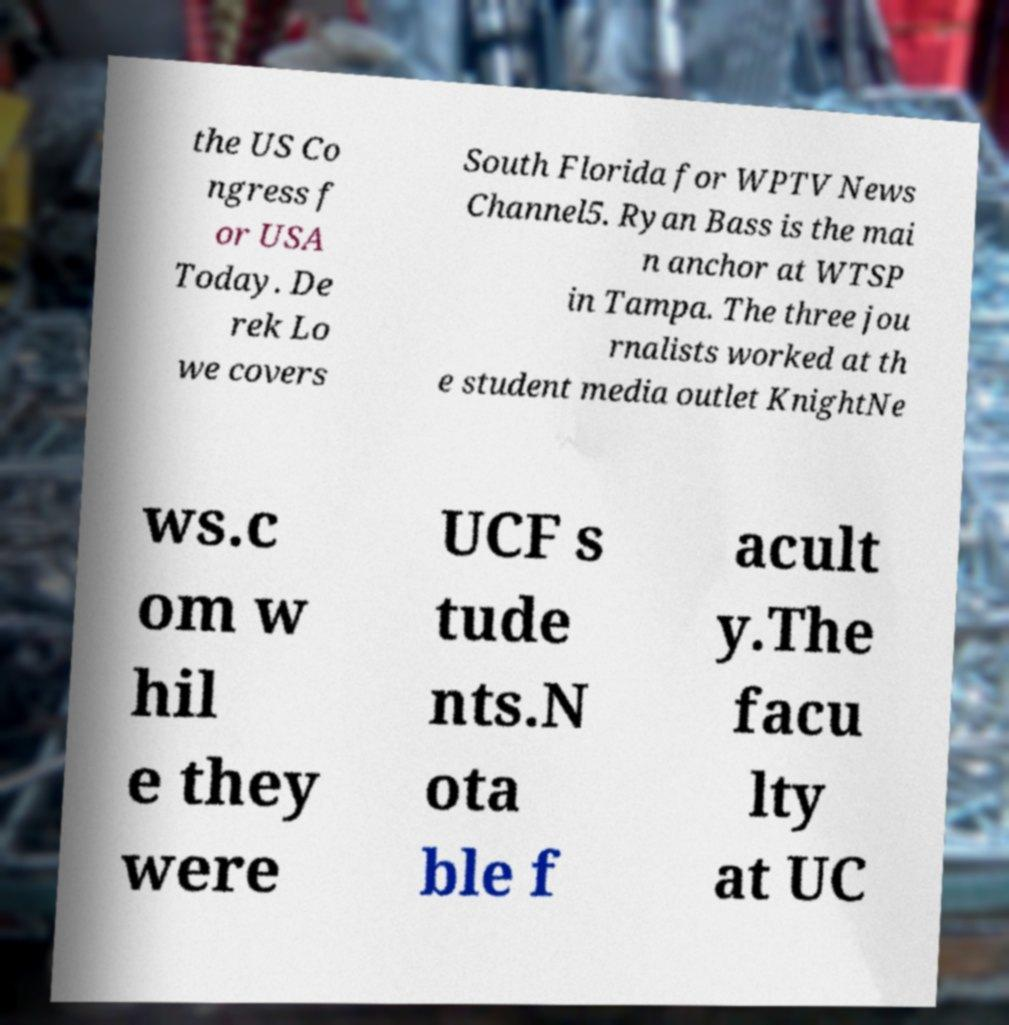Please read and relay the text visible in this image. What does it say? the US Co ngress f or USA Today. De rek Lo we covers South Florida for WPTV News Channel5. Ryan Bass is the mai n anchor at WTSP in Tampa. The three jou rnalists worked at th e student media outlet KnightNe ws.c om w hil e they were UCF s tude nts.N ota ble f acult y.The facu lty at UC 